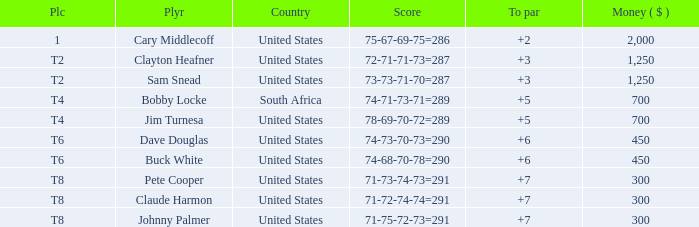What Country is Player Sam Snead with a To par of less than 5 from? United States. 